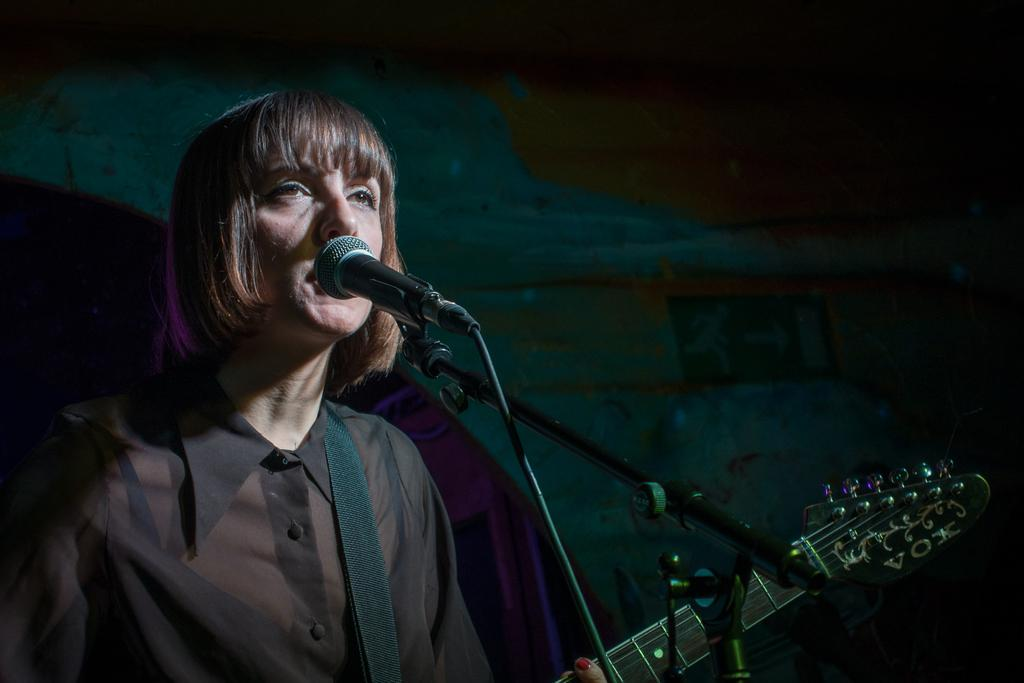What is the general color scheme of the background in the image? The background of the image is dark. Who is the main subject in the image? There is a woman in the image. What is the woman doing in the image? The woman is in front of a microphone and holding a guitar. What is the woman wearing in the image? The woman is wearing a black color transparent shirt. What type of animal can be seen interacting with the woman in the image? There is no animal present in the image; the woman is standing alone in front of a microphone and holding a guitar. Is there a box visible in the image? No, there is no box present in the image. 